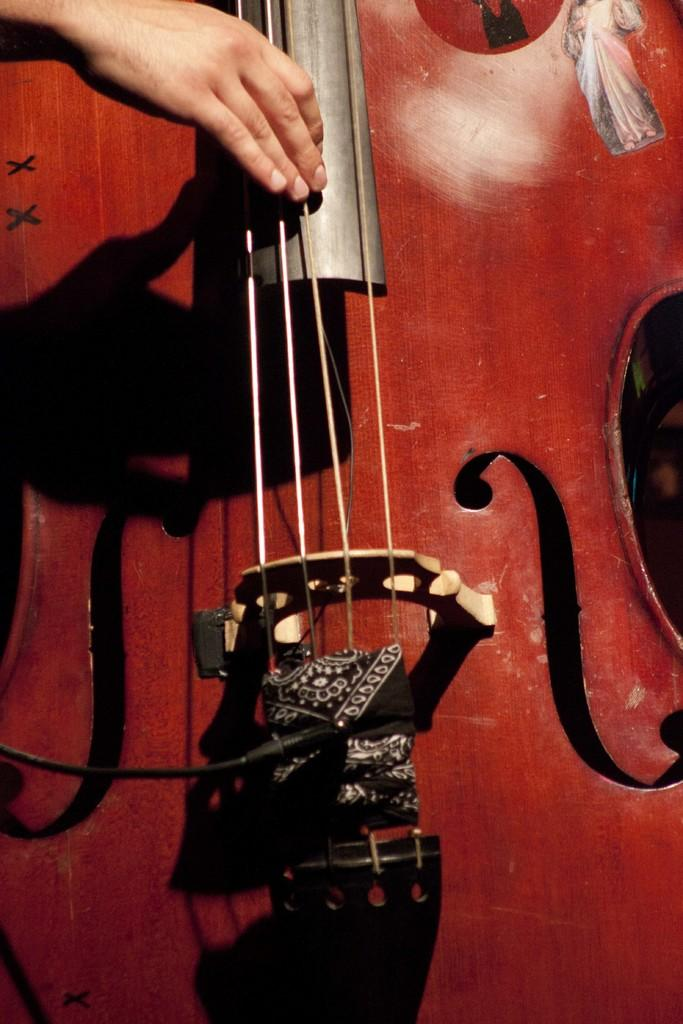What object in the image is associated with making music? There is a musical instrument in the image. Can you describe any human body parts visible in the image? A person's hand is visible in the top left corner of the image. What type of pie is being prepared in the image? There is no pie present in the image. What type of polish is being applied to the musical instrument in the image? There is no polish or indication of polishing in the image. 